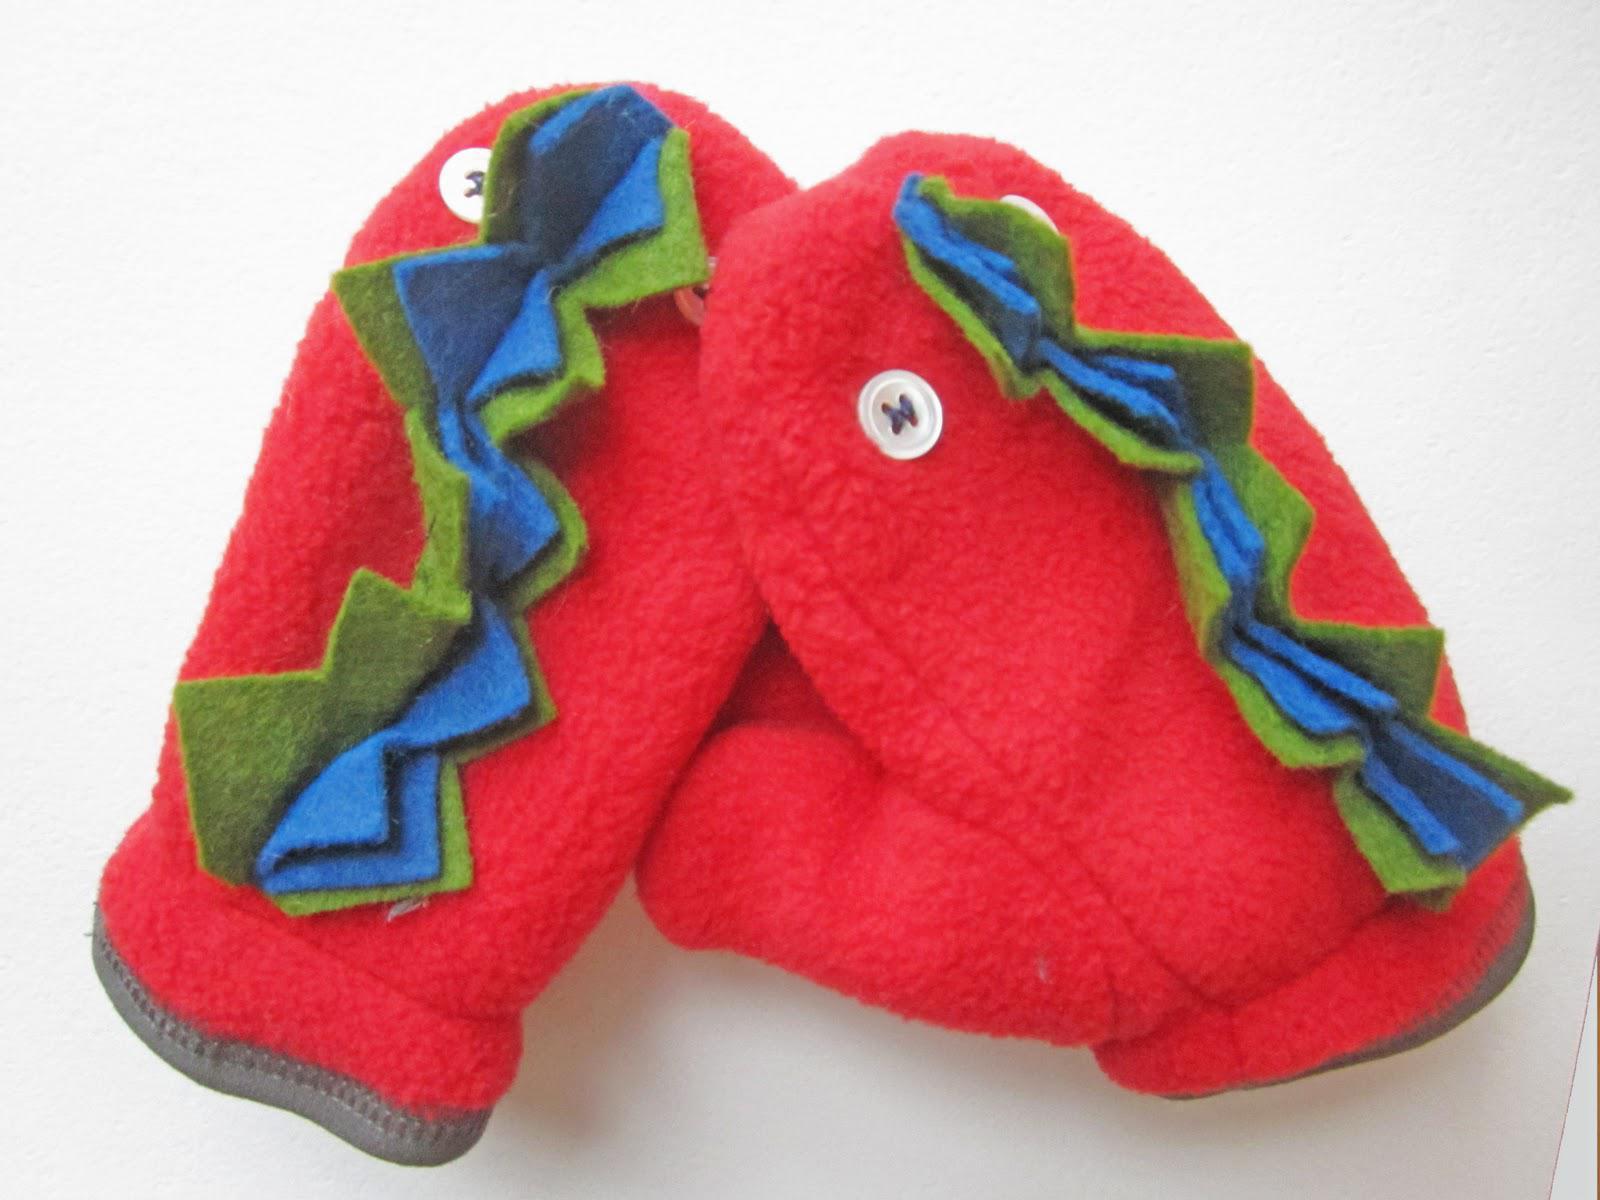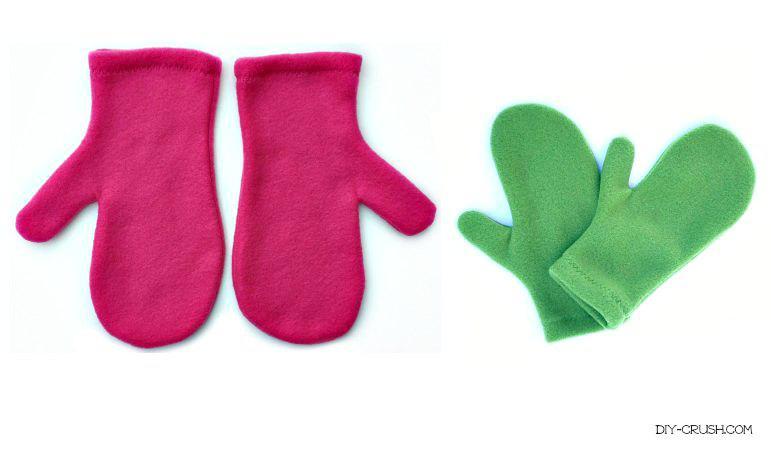The first image is the image on the left, the second image is the image on the right. For the images displayed, is the sentence "The right image shows solid red mittens with a joined 'muff' between them." factually correct? Answer yes or no. No. The first image is the image on the left, the second image is the image on the right. Assess this claim about the two images: "All of the mittens in the image on the right are red.". Correct or not? Answer yes or no. No. 